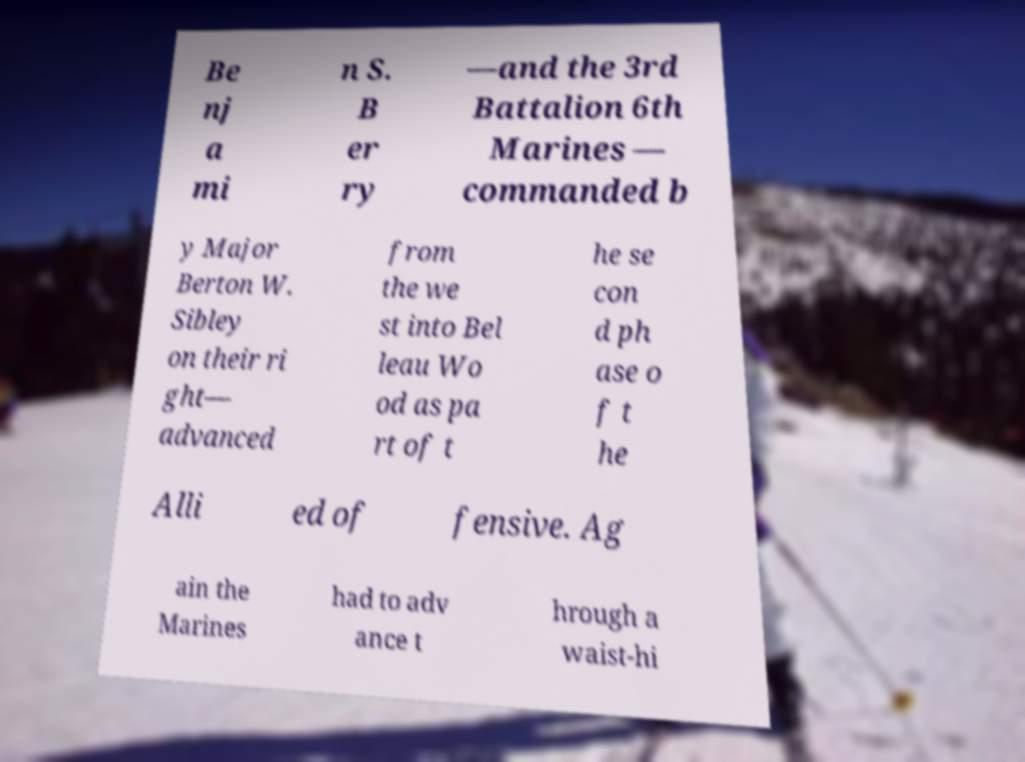Could you assist in decoding the text presented in this image and type it out clearly? Be nj a mi n S. B er ry —and the 3rd Battalion 6th Marines — commanded b y Major Berton W. Sibley on their ri ght— advanced from the we st into Bel leau Wo od as pa rt of t he se con d ph ase o f t he Alli ed of fensive. Ag ain the Marines had to adv ance t hrough a waist-hi 